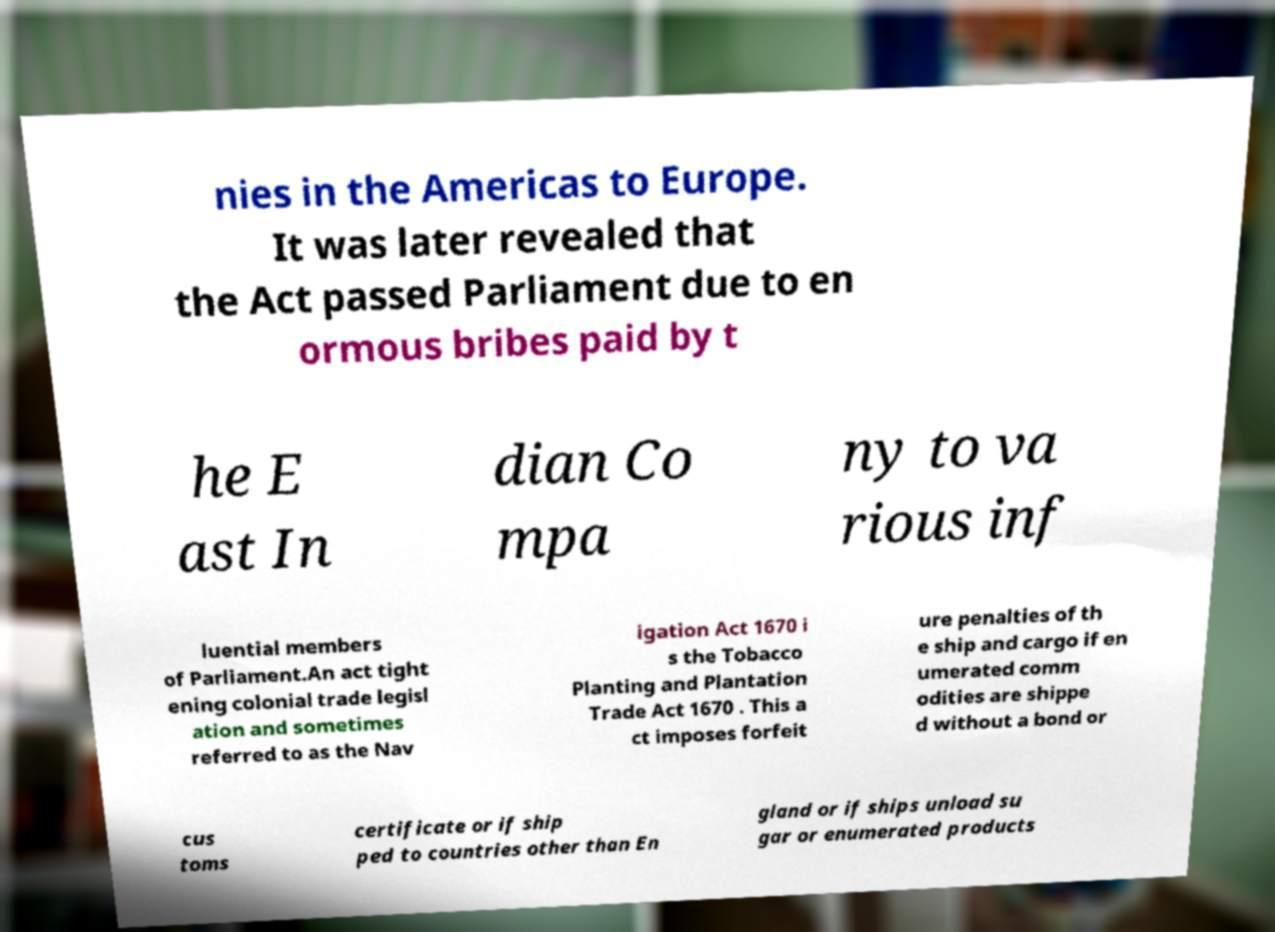Could you assist in decoding the text presented in this image and type it out clearly? nies in the Americas to Europe. It was later revealed that the Act passed Parliament due to en ormous bribes paid by t he E ast In dian Co mpa ny to va rious inf luential members of Parliament.An act tight ening colonial trade legisl ation and sometimes referred to as the Nav igation Act 1670 i s the Tobacco Planting and Plantation Trade Act 1670 . This a ct imposes forfeit ure penalties of th e ship and cargo if en umerated comm odities are shippe d without a bond or cus toms certificate or if ship ped to countries other than En gland or if ships unload su gar or enumerated products 